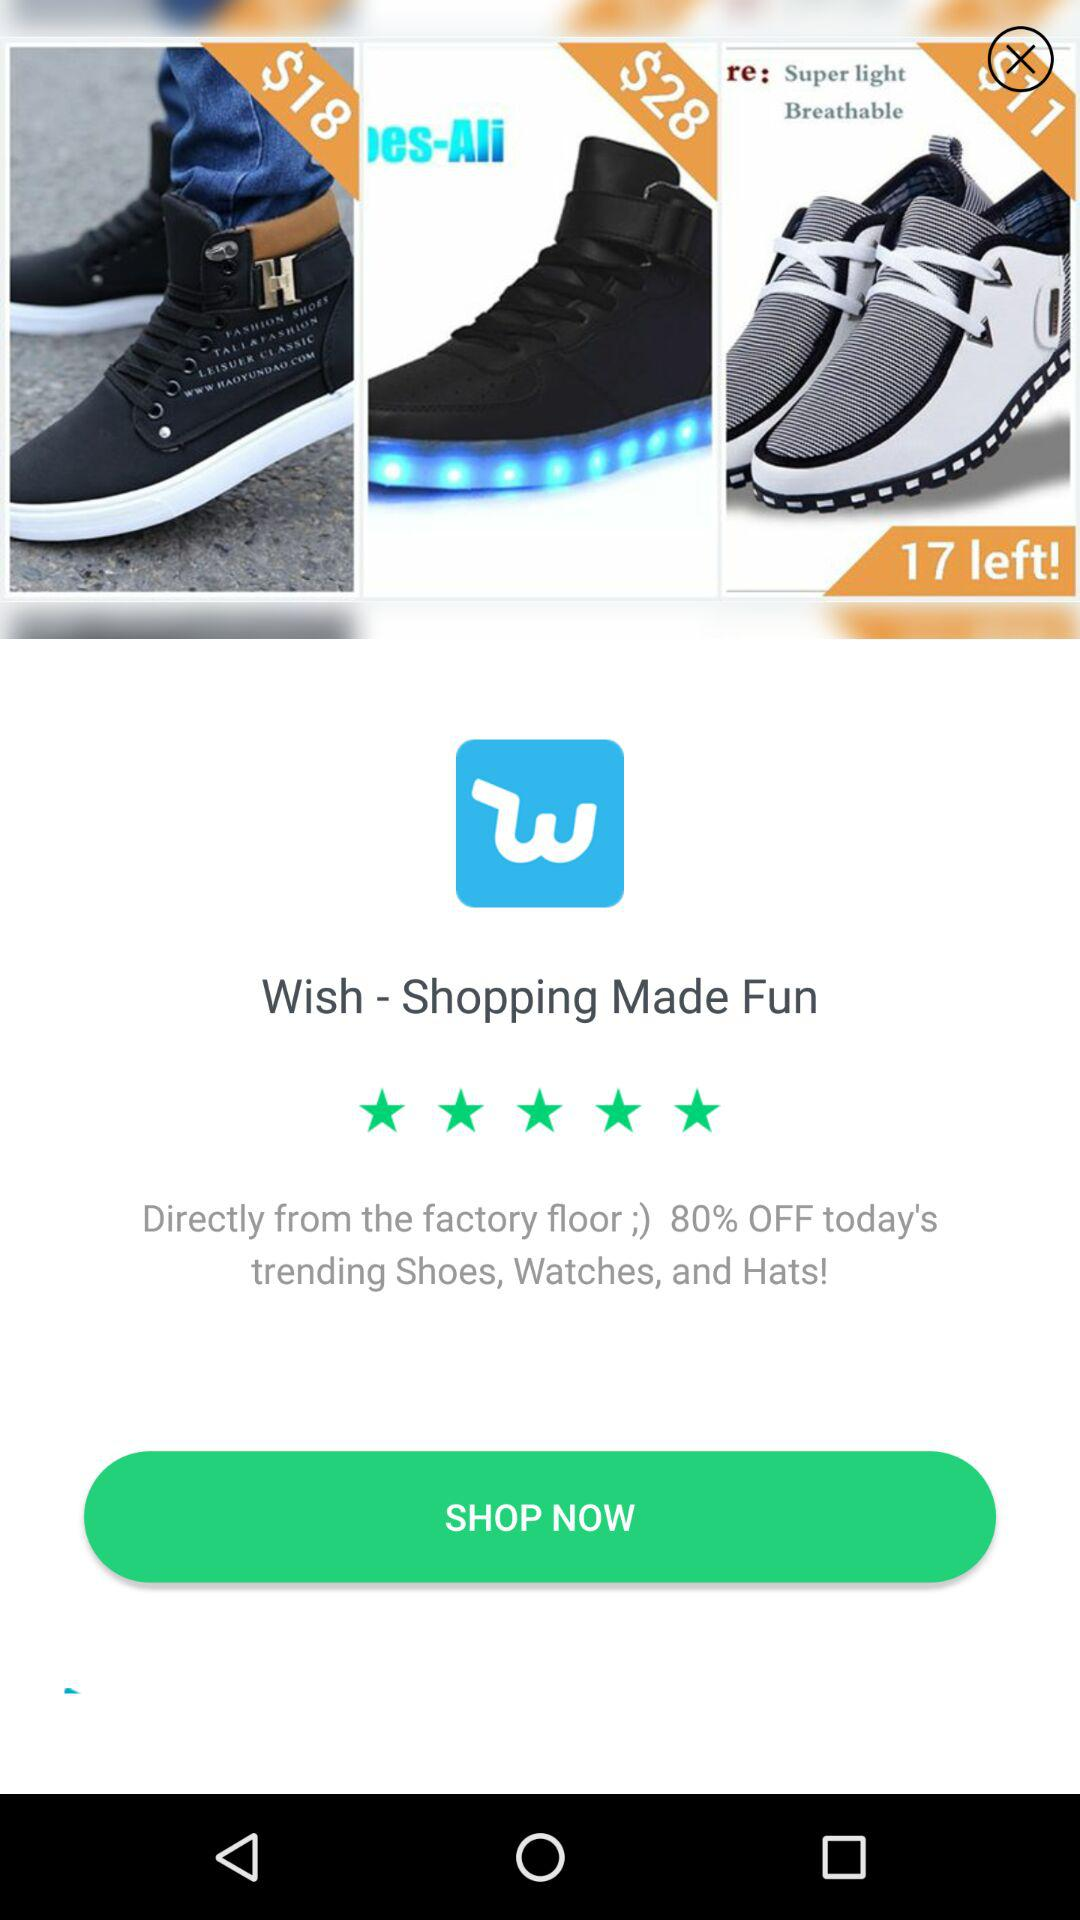What is the rating for the application? The rating for the application is 5 stars. 